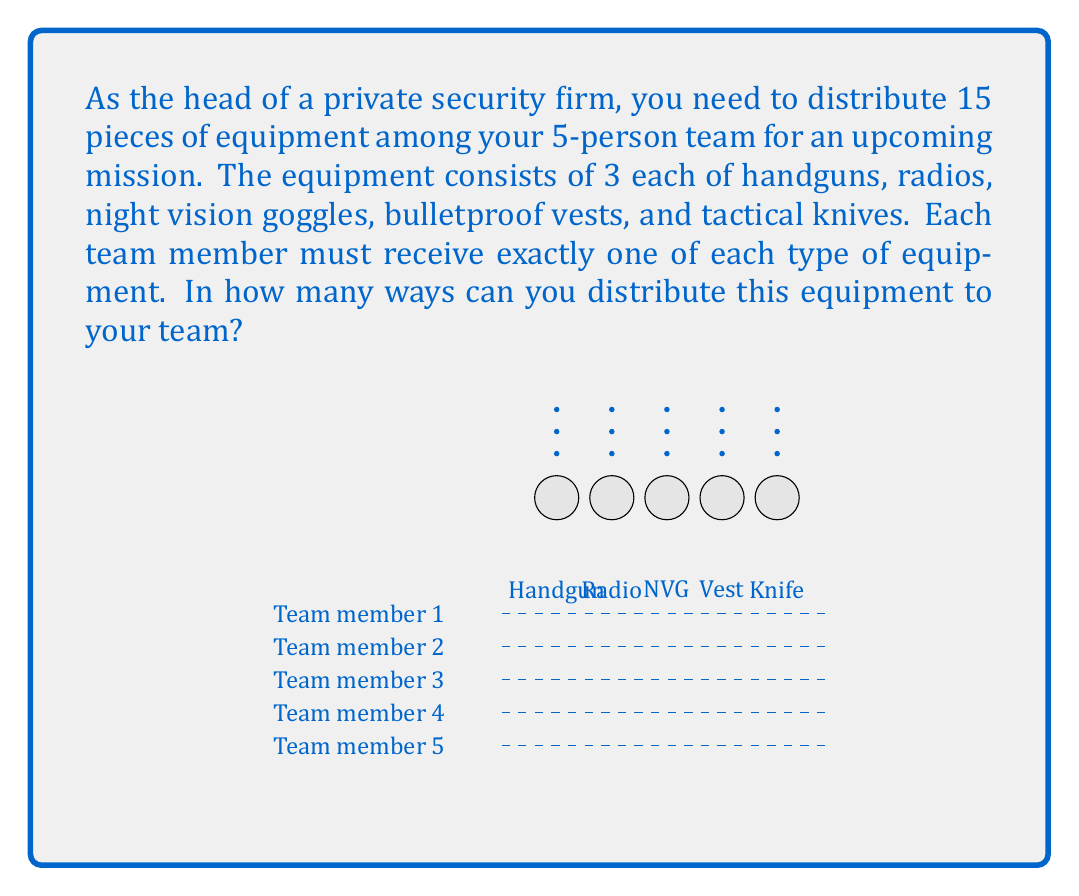Give your solution to this math problem. Let's approach this step-by-step:

1) We need to distribute 5 different types of equipment, and for each type, we're choosing from 3 identical pieces.

2) For the first type of equipment (let's say handguns):
   - We have 5 choices for the first handgun
   - 4 choices for the second
   - 3 choices for the third
   - 2 choices for the fourth
   - 1 choice for the last

   This gives us $5!$ ways to distribute the handguns.

3) The same logic applies to each type of equipment. So we have $5!$ ways for each of the 5 types.

4) By the multiplication principle, the total number of ways to distribute all equipment is:

   $$(5!)^5$$

5) Let's calculate this:
   $5! = 5 \times 4 \times 3 \times 2 \times 1 = 120$
   
   $(120)^5 = 24,883,200,000$

Therefore, there are 24,883,200,000 ways to distribute the equipment.
Answer: $24,883,200,000$ 